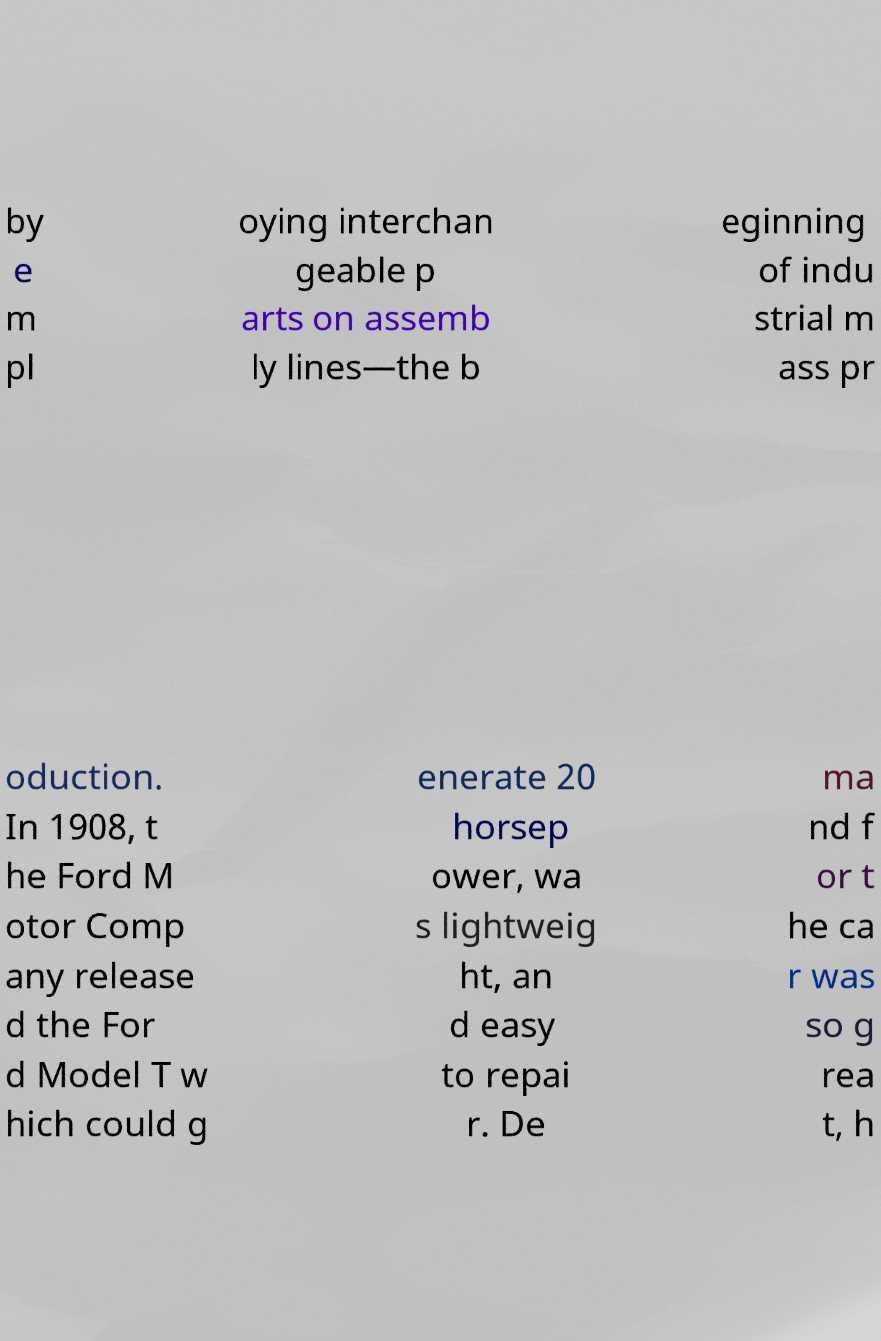What messages or text are displayed in this image? I need them in a readable, typed format. by e m pl oying interchan geable p arts on assemb ly lines—the b eginning of indu strial m ass pr oduction. In 1908, t he Ford M otor Comp any release d the For d Model T w hich could g enerate 20 horsep ower, wa s lightweig ht, an d easy to repai r. De ma nd f or t he ca r was so g rea t, h 